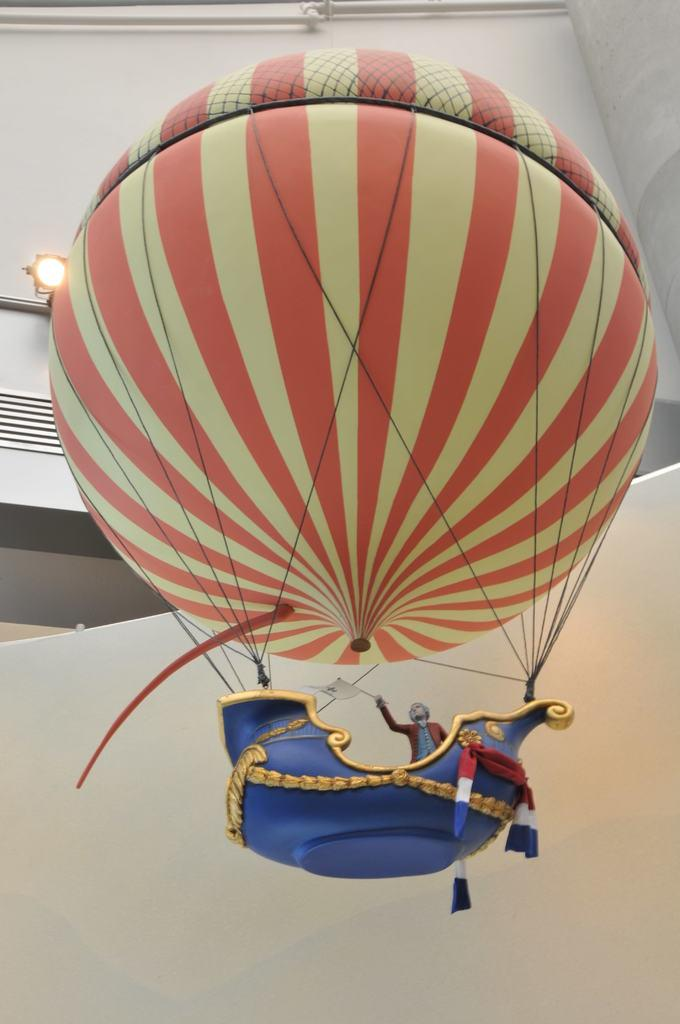What is the man in the image holding? The man is holding a flag with his hand. What else can be seen in the image besides the man and the flag? There is a parachute in the image. What can be seen in the background of the image? There is light, a wall, and pipes in the background of the image. What type of quarter is being used to play music in the image? There is no quarter or music being played in the image; it features a man holding a flag, a parachute, and background elements such as light, a wall, and pipes. 